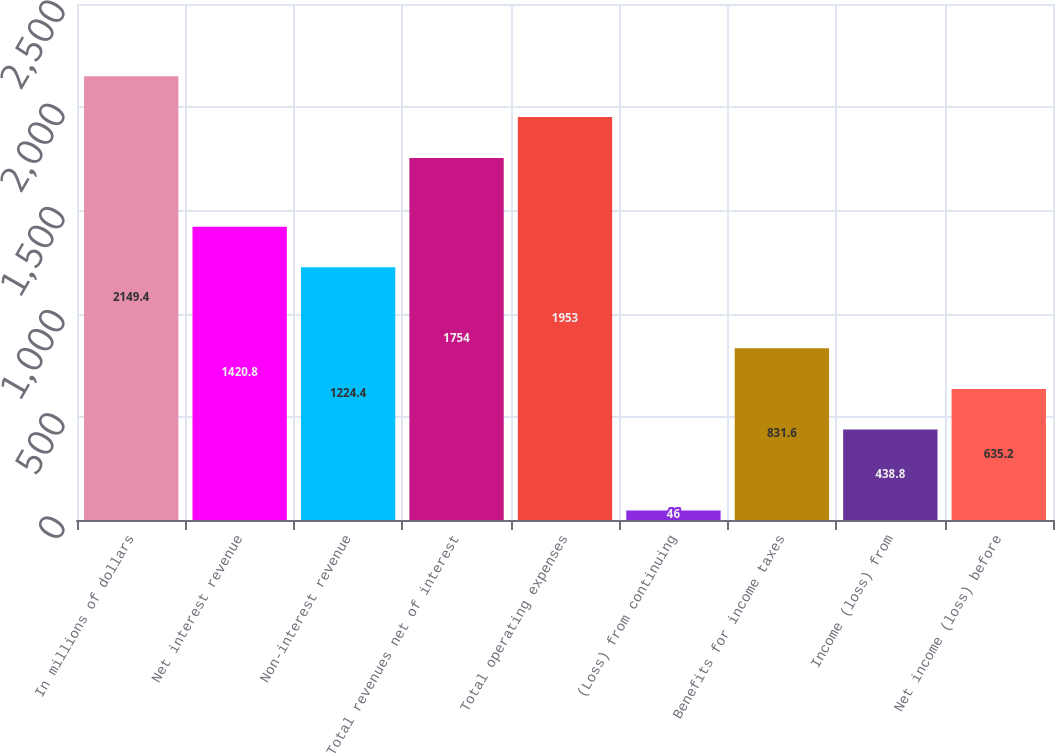Convert chart. <chart><loc_0><loc_0><loc_500><loc_500><bar_chart><fcel>In millions of dollars<fcel>Net interest revenue<fcel>Non-interest revenue<fcel>Total revenues net of interest<fcel>Total operating expenses<fcel>(Loss) from continuing<fcel>Benefits for income taxes<fcel>Income (loss) from<fcel>Net income (loss) before<nl><fcel>2149.4<fcel>1420.8<fcel>1224.4<fcel>1754<fcel>1953<fcel>46<fcel>831.6<fcel>438.8<fcel>635.2<nl></chart> 